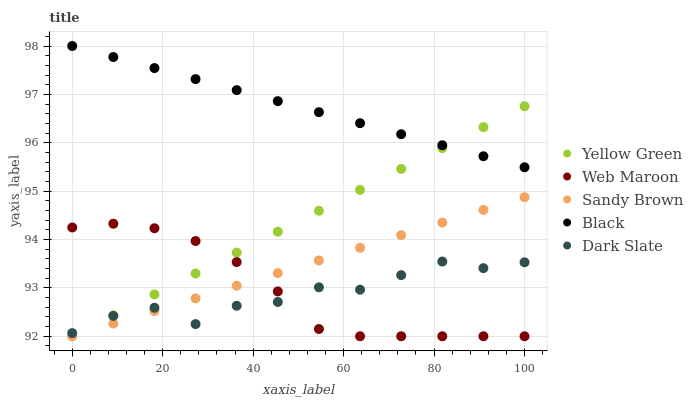Does Dark Slate have the minimum area under the curve?
Answer yes or no. Yes. Does Black have the maximum area under the curve?
Answer yes or no. Yes. Does Web Maroon have the minimum area under the curve?
Answer yes or no. No. Does Web Maroon have the maximum area under the curve?
Answer yes or no. No. Is Yellow Green the smoothest?
Answer yes or no. Yes. Is Dark Slate the roughest?
Answer yes or no. Yes. Is Web Maroon the smoothest?
Answer yes or no. No. Is Web Maroon the roughest?
Answer yes or no. No. Does Sandy Brown have the lowest value?
Answer yes or no. Yes. Does Black have the lowest value?
Answer yes or no. No. Does Black have the highest value?
Answer yes or no. Yes. Does Web Maroon have the highest value?
Answer yes or no. No. Is Sandy Brown less than Black?
Answer yes or no. Yes. Is Black greater than Web Maroon?
Answer yes or no. Yes. Does Black intersect Yellow Green?
Answer yes or no. Yes. Is Black less than Yellow Green?
Answer yes or no. No. Is Black greater than Yellow Green?
Answer yes or no. No. Does Sandy Brown intersect Black?
Answer yes or no. No. 